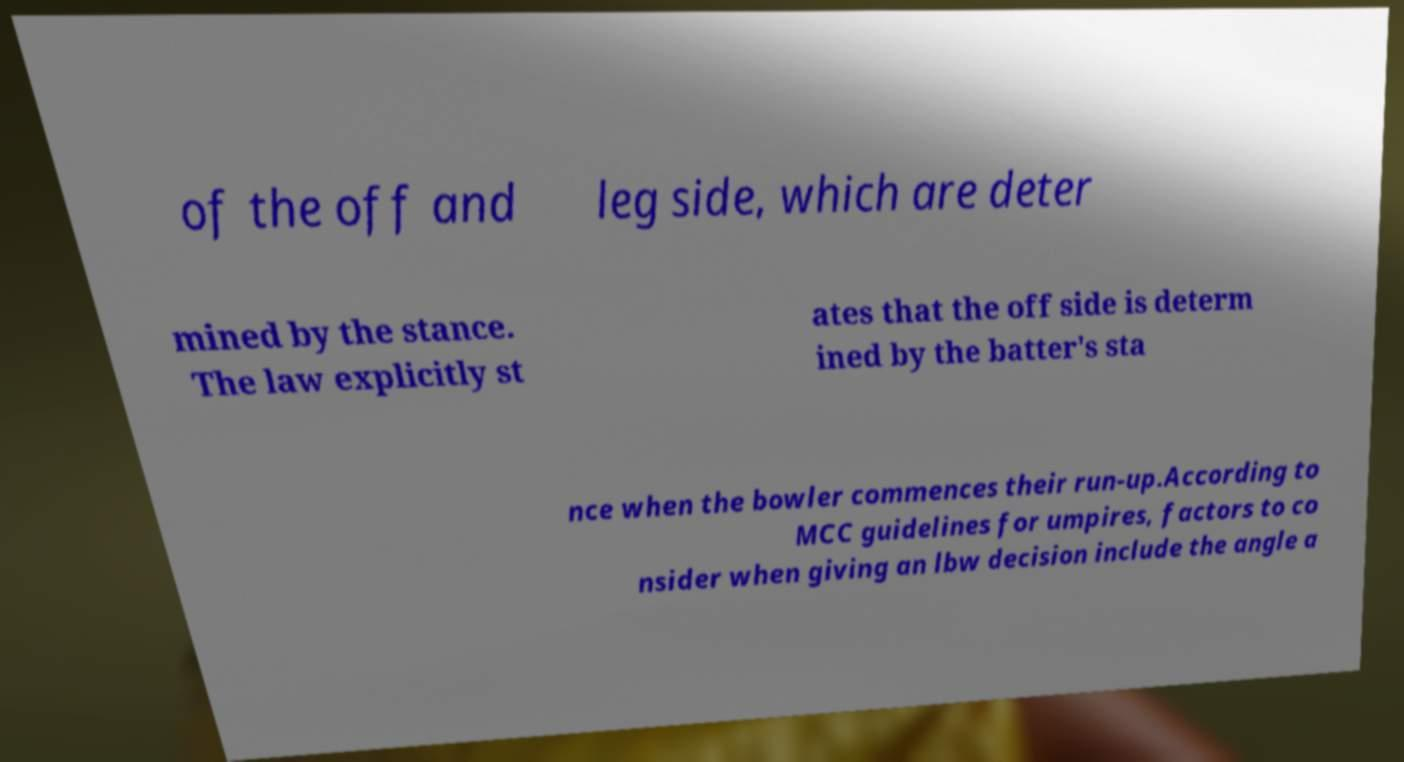Please read and relay the text visible in this image. What does it say? of the off and leg side, which are deter mined by the stance. The law explicitly st ates that the off side is determ ined by the batter's sta nce when the bowler commences their run-up.According to MCC guidelines for umpires, factors to co nsider when giving an lbw decision include the angle a 